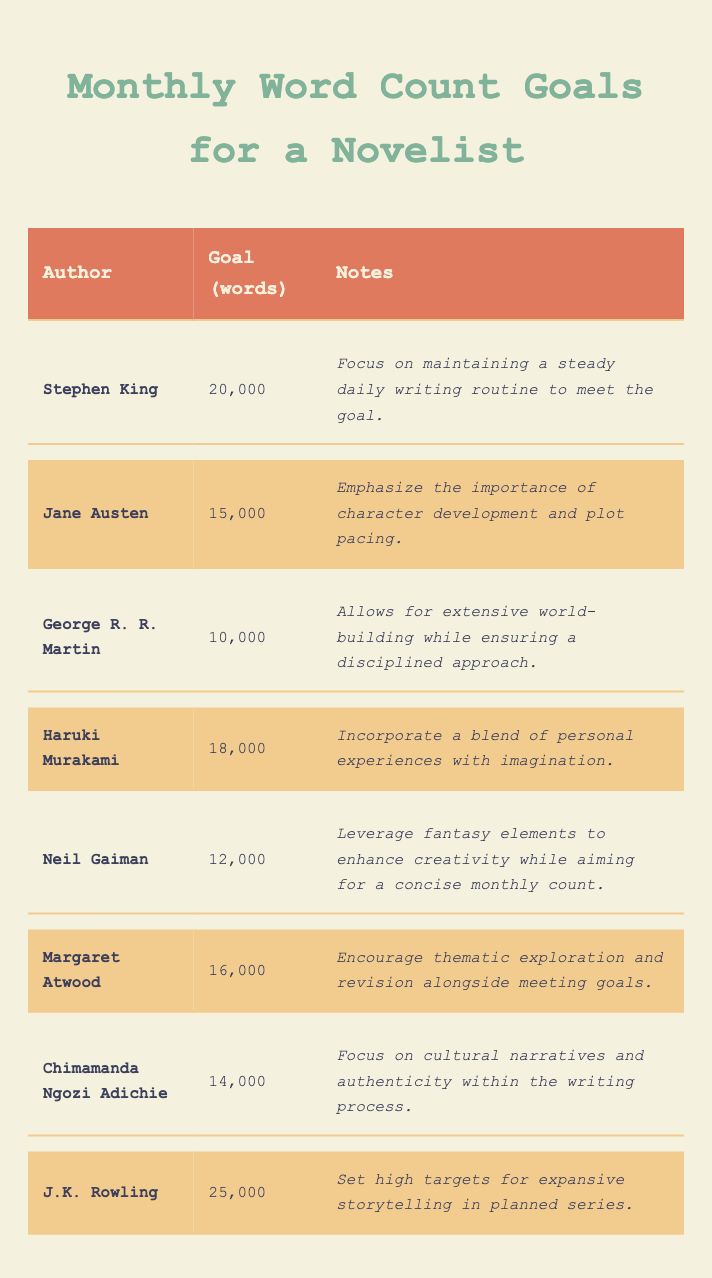What is the word count goal for J.K. Rowling? The table lists J.K. Rowling's goal under the "Goal (words)" column, which shows 25,000.
Answer: 25,000 Which author has the highest word count goal? By examining the "Goal (words)" column, J.K. Rowling's goal of 25,000 is higher than all others.
Answer: J.K. Rowling What is the average word count goal of all the authors? To find the average, sum up all the goals: (20,000 + 15,000 + 10,000 + 18,000 + 12,000 + 16,000 + 14,000 + 25,000) = 120,000. Then divide by the number of authors (8): 120,000 / 8 = 15,000.
Answer: 15,000 Does George R. R. Martin have a goal greater than 15,000 words? George R. R. Martin's goal is 10,000, which is less than 15,000, making the statement false.
Answer: No What is the difference in word count goals between Stephen King and Neil Gaiman? Stephen King's goal is 20,000 and Neil Gaiman's is 12,000. The difference is 20,000 - 12,000 = 8,000.
Answer: 8,000 Which authors have goals that reflect a focus on character development? The table notes character development as a focus for Jane Austen, highlighted in her notes.
Answer: Jane Austen Are there any authors with a goal of exactly 14,000 words? The table shows Chimamanda Ngozi Adichie's goal is 14,000, confirming the statement as true.
Answer: Yes How many authors have word count goals greater than 15,000? The authors with goals above 15,000 are Stephen King (20,000), Haruki Murakami (18,000), Margaret Atwood (16,000), and J.K. Rowling (25,000), totalling 4 authors.
Answer: 4 What percentage of the authors have goals below 15,000 words? The authors with goals below 15,000 are George R. R. Martin (10,000) and Neil Gaiman (12,000), which is 2 out of 8. Therefore, (2/8) * 100 = 25%.
Answer: 25% If we combine the goals of George R. R. Martin and Neil Gaiman, what is the total? Adding their goals: 10,000 + 12,000 = 22,000 gives the combined total.
Answer: 22,000 